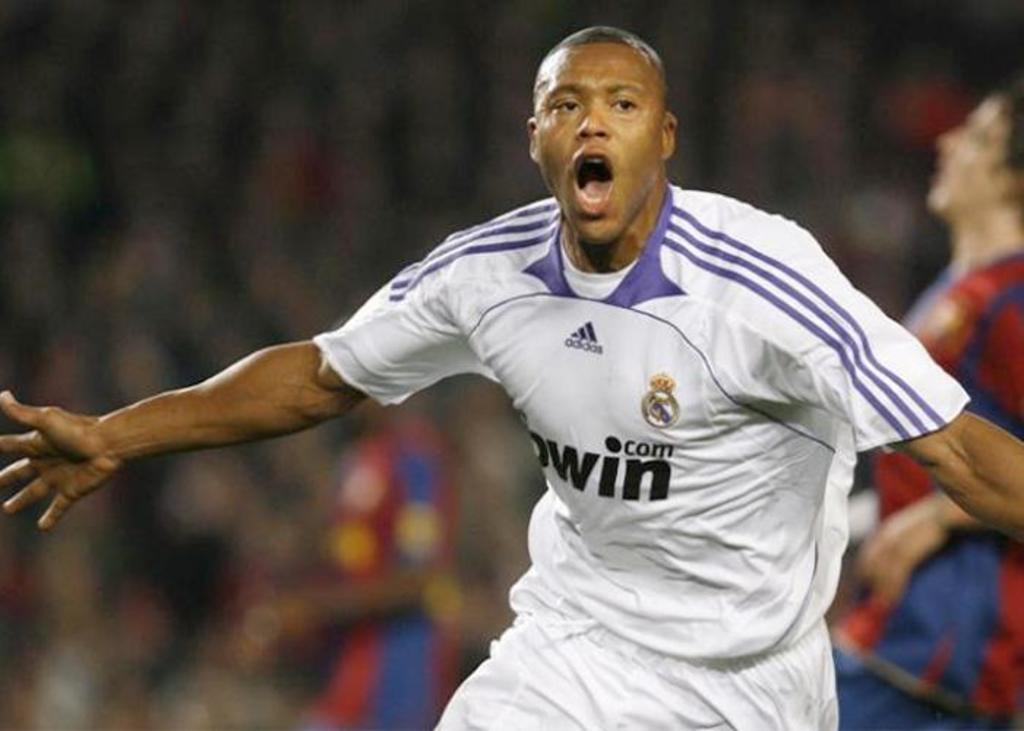Can you describe this image briefly? In this image, there are a few people. We can also see the blurred background. 